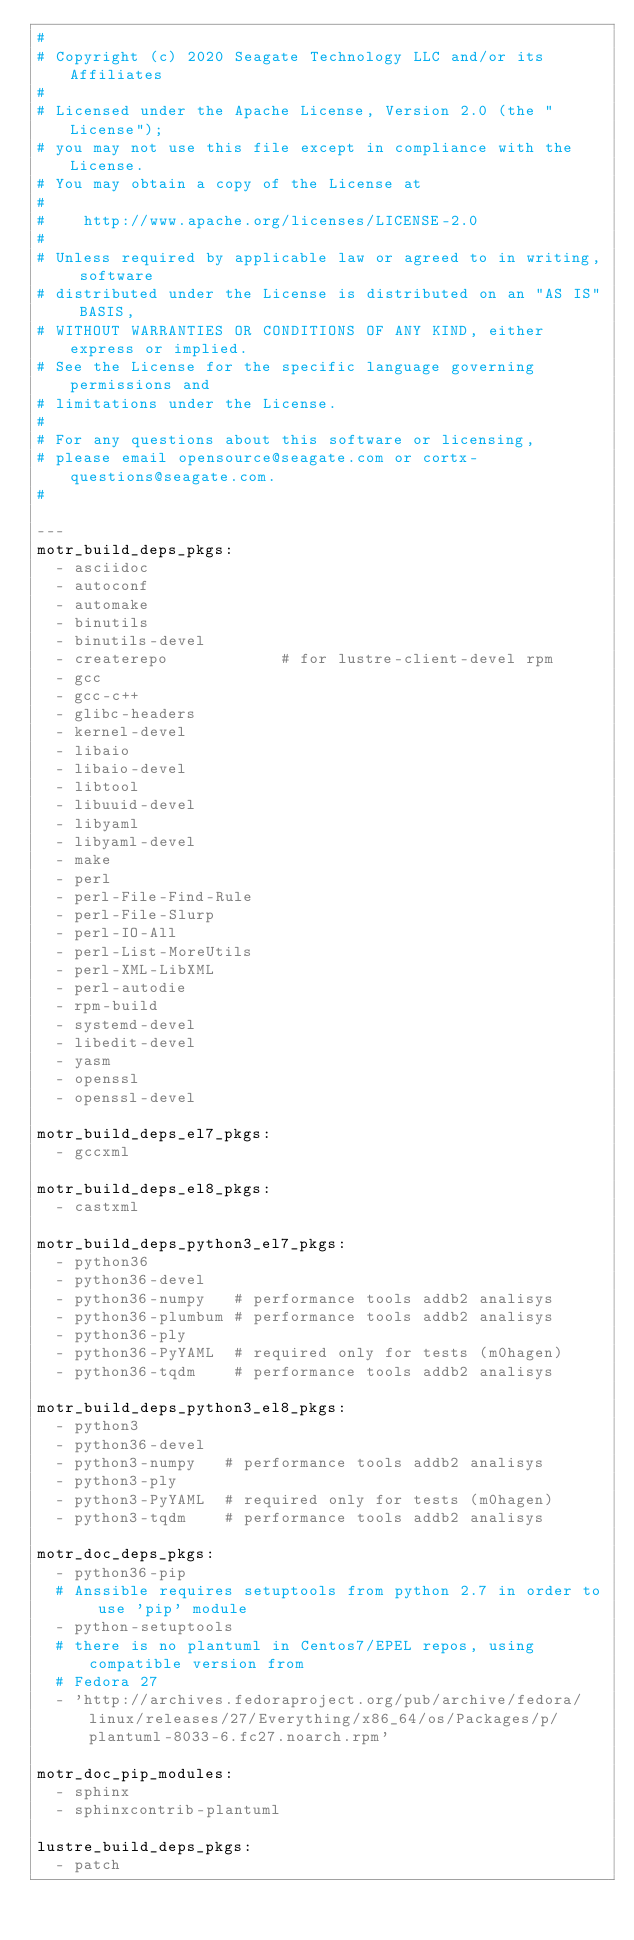<code> <loc_0><loc_0><loc_500><loc_500><_YAML_>#
# Copyright (c) 2020 Seagate Technology LLC and/or its Affiliates
#
# Licensed under the Apache License, Version 2.0 (the "License");
# you may not use this file except in compliance with the License.
# You may obtain a copy of the License at
#
#    http://www.apache.org/licenses/LICENSE-2.0
#
# Unless required by applicable law or agreed to in writing, software
# distributed under the License is distributed on an "AS IS" BASIS,
# WITHOUT WARRANTIES OR CONDITIONS OF ANY KIND, either express or implied.
# See the License for the specific language governing permissions and
# limitations under the License.
#
# For any questions about this software or licensing,
# please email opensource@seagate.com or cortx-questions@seagate.com.
#

---
motr_build_deps_pkgs:
  - asciidoc
  - autoconf
  - automake
  - binutils
  - binutils-devel
  - createrepo            # for lustre-client-devel rpm
  - gcc
  - gcc-c++
  - glibc-headers
  - kernel-devel
  - libaio
  - libaio-devel
  - libtool
  - libuuid-devel
  - libyaml
  - libyaml-devel
  - make
  - perl
  - perl-File-Find-Rule
  - perl-File-Slurp
  - perl-IO-All
  - perl-List-MoreUtils
  - perl-XML-LibXML
  - perl-autodie
  - rpm-build
  - systemd-devel
  - libedit-devel
  - yasm
  - openssl
  - openssl-devel

motr_build_deps_el7_pkgs:
  - gccxml

motr_build_deps_el8_pkgs:
  - castxml

motr_build_deps_python3_el7_pkgs:
  - python36
  - python36-devel
  - python36-numpy   # performance tools addb2 analisys
  - python36-plumbum # performance tools addb2 analisys
  - python36-ply
  - python36-PyYAML  # required only for tests (m0hagen)
  - python36-tqdm    # performance tools addb2 analisys

motr_build_deps_python3_el8_pkgs:
  - python3
  - python36-devel
  - python3-numpy   # performance tools addb2 analisys
  - python3-ply
  - python3-PyYAML  # required only for tests (m0hagen)
  - python3-tqdm    # performance tools addb2 analisys

motr_doc_deps_pkgs:
  - python36-pip
  # Anssible requires setuptools from python 2.7 in order to use 'pip' module
  - python-setuptools
  # there is no plantuml in Centos7/EPEL repos, using compatible version from
  # Fedora 27
  - 'http://archives.fedoraproject.org/pub/archive/fedora/linux/releases/27/Everything/x86_64/os/Packages/p/plantuml-8033-6.fc27.noarch.rpm'

motr_doc_pip_modules:
  - sphinx
  - sphinxcontrib-plantuml

lustre_build_deps_pkgs:
  - patch
</code> 